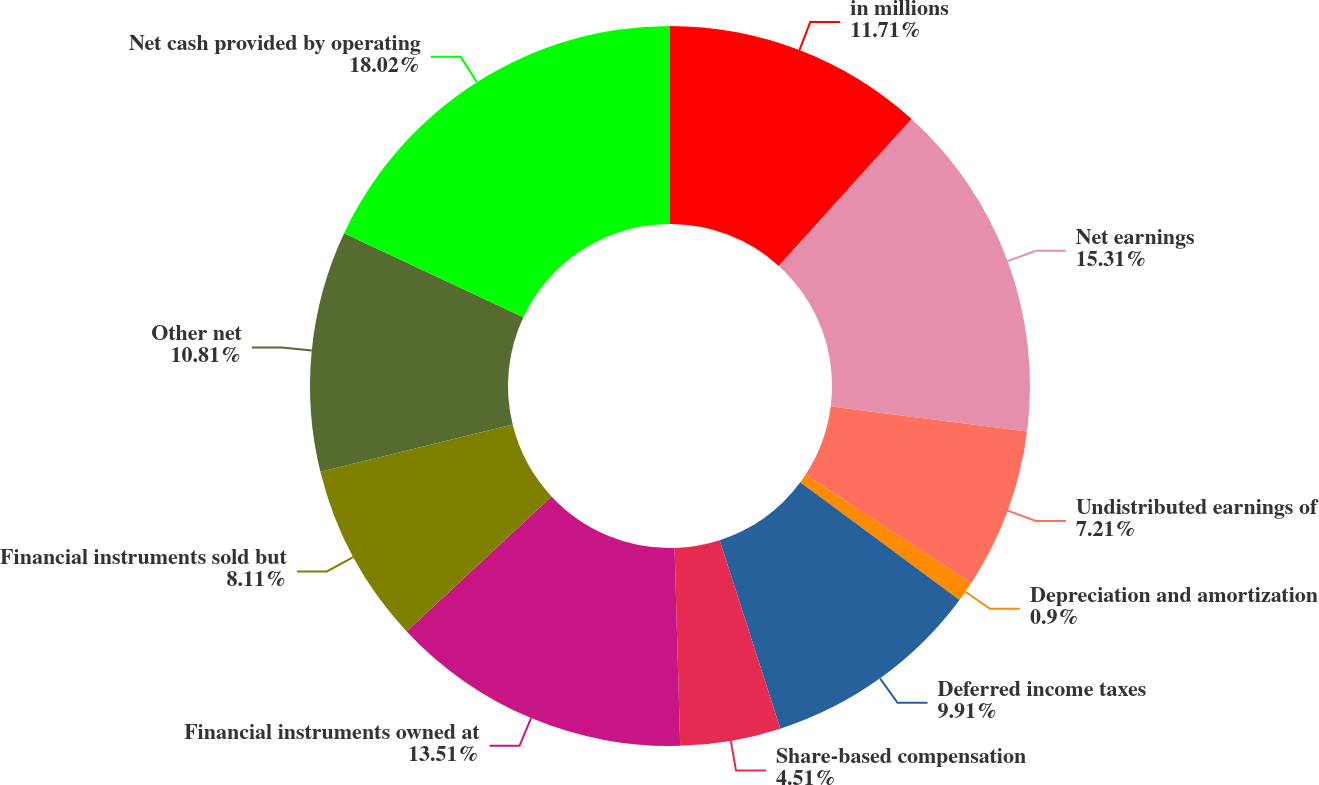Convert chart to OTSL. <chart><loc_0><loc_0><loc_500><loc_500><pie_chart><fcel>in millions<fcel>Net earnings<fcel>Undistributed earnings of<fcel>Depreciation and amortization<fcel>Deferred income taxes<fcel>Share-based compensation<fcel>Financial instruments owned at<fcel>Financial instruments sold but<fcel>Other net<fcel>Net cash provided by operating<nl><fcel>11.71%<fcel>15.31%<fcel>7.21%<fcel>0.9%<fcel>9.91%<fcel>4.51%<fcel>13.51%<fcel>8.11%<fcel>10.81%<fcel>18.02%<nl></chart> 